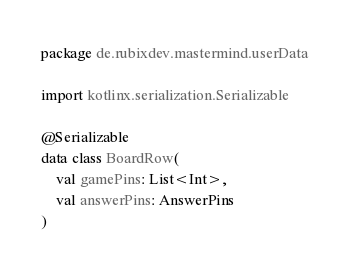<code> <loc_0><loc_0><loc_500><loc_500><_Kotlin_>package de.rubixdev.mastermind.userData

import kotlinx.serialization.Serializable

@Serializable
data class BoardRow(
    val gamePins: List<Int>,
    val answerPins: AnswerPins
)
</code> 